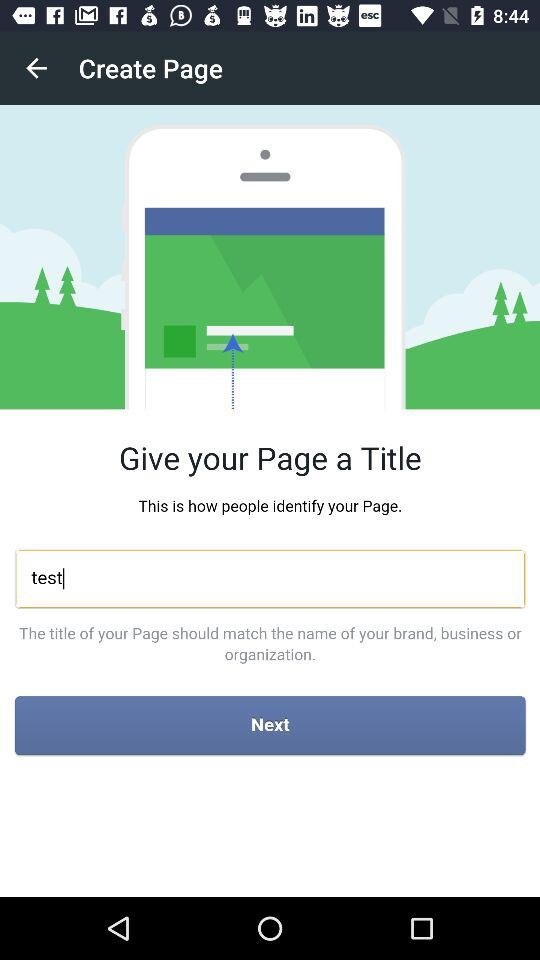By what user name can the application be continued? The user name is Raphael Tan. 